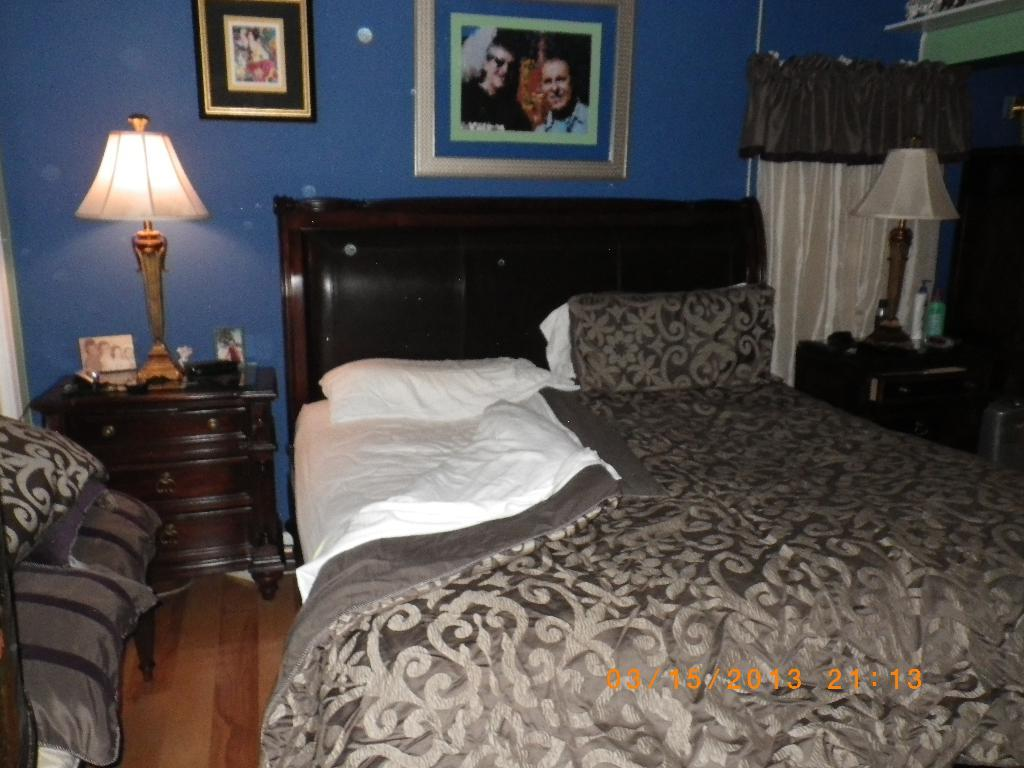What piece of furniture is located on the left side of the image? There is a bed on the left side of the image. What is the location of the lamp in the image? The lamp is on a cupboard in the image. Where is the cupboard situated in the image? The cupboard is in the background of the image. What is attached to a wall in the image? There is a frame attached to a wall in the image. Where is the frame located in the image? The frame is in the background of the image. What type of window treatment is present in the image? There is a curtain in the image. How many twigs are used to support the bed in the image? There are no twigs present in the image; the bed is supported by a frame or legs. What type of coil is visible on the bed in the image? There is no coil visible on the bed in the image; it is a solid piece of furniture. 